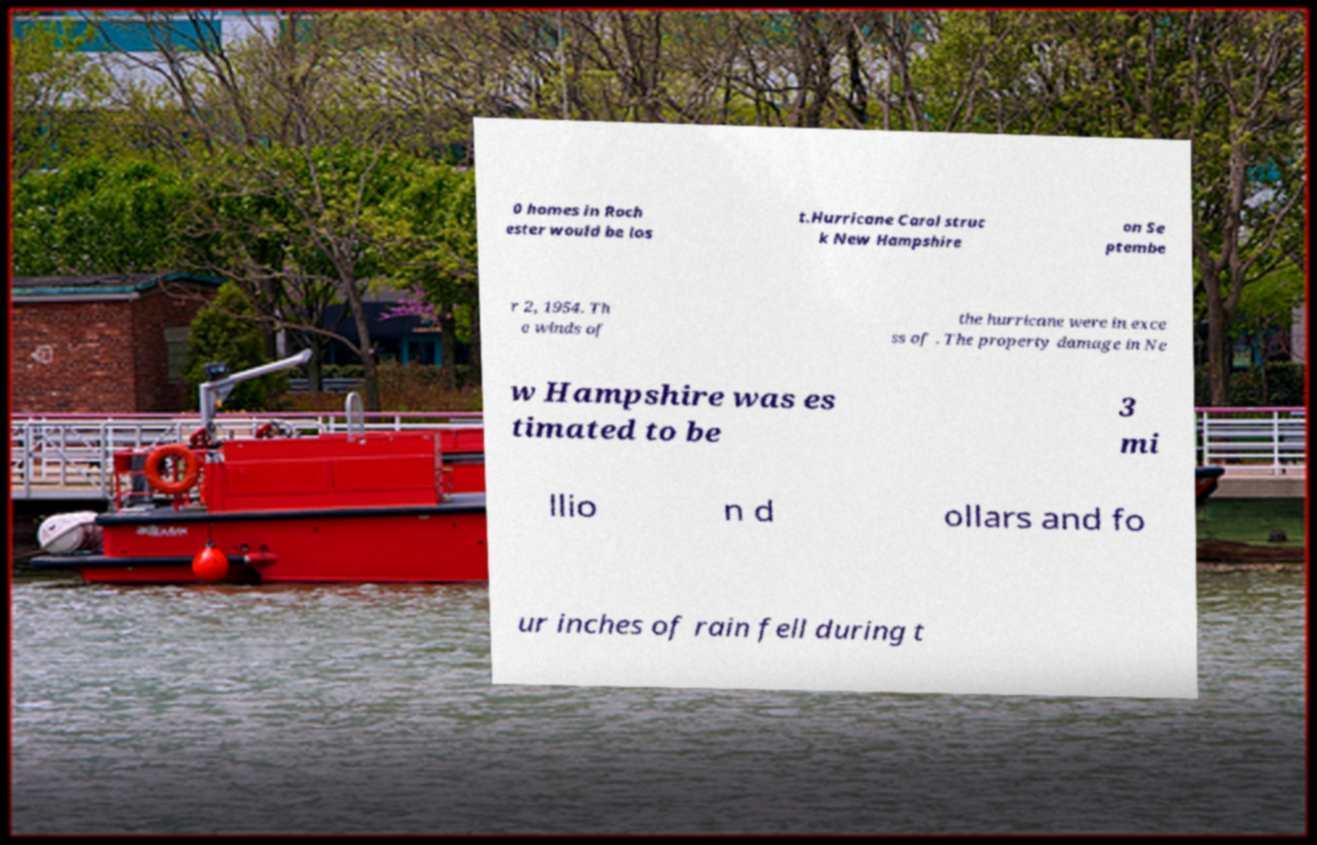What messages or text are displayed in this image? I need them in a readable, typed format. 0 homes in Roch ester would be los t.Hurricane Carol struc k New Hampshire on Se ptembe r 2, 1954. Th e winds of the hurricane were in exce ss of . The property damage in Ne w Hampshire was es timated to be 3 mi llio n d ollars and fo ur inches of rain fell during t 